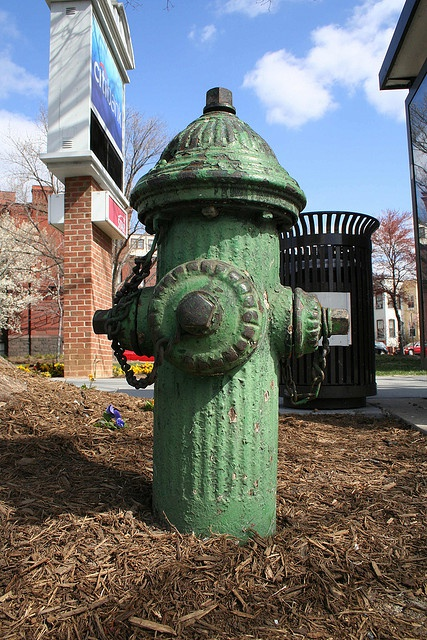Describe the objects in this image and their specific colors. I can see fire hydrant in lightblue, black, darkgreen, darkgray, and green tones, car in lightblue, black, gray, darkgray, and lightgray tones, and car in lightblue, darkgray, brown, gray, and lightgray tones in this image. 